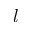Convert formula to latex. <formula><loc_0><loc_0><loc_500><loc_500>l</formula> 